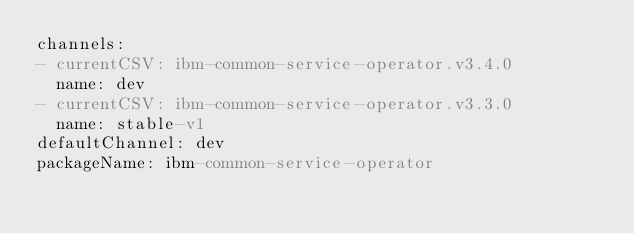<code> <loc_0><loc_0><loc_500><loc_500><_YAML_>channels:
- currentCSV: ibm-common-service-operator.v3.4.0
  name: dev
- currentCSV: ibm-common-service-operator.v3.3.0
  name: stable-v1
defaultChannel: dev
packageName: ibm-common-service-operator
</code> 